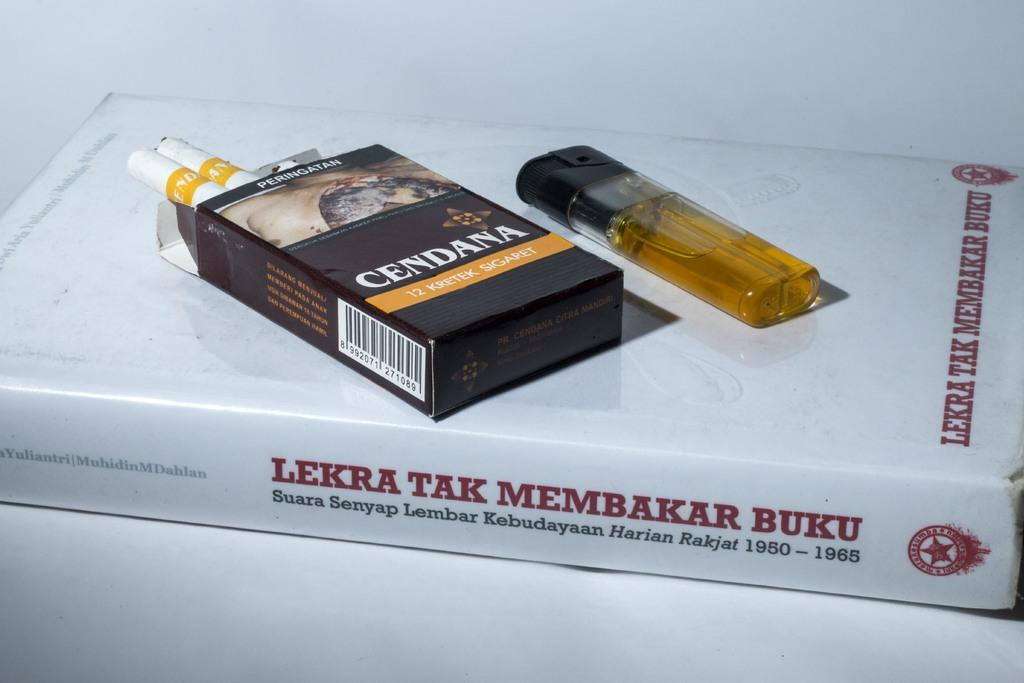<image>
Relay a brief, clear account of the picture shown. A pack of Cendana Sigaret(s) and a lighter lie on top of a copy of LEKTRA TAK MEMBAKAR BUKU. 